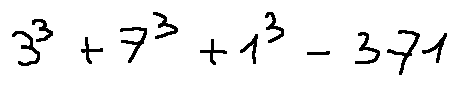Convert formula to latex. <formula><loc_0><loc_0><loc_500><loc_500>3 ^ { 3 } + 7 ^ { 3 } + 1 ^ { 3 } = 3 7 1</formula> 